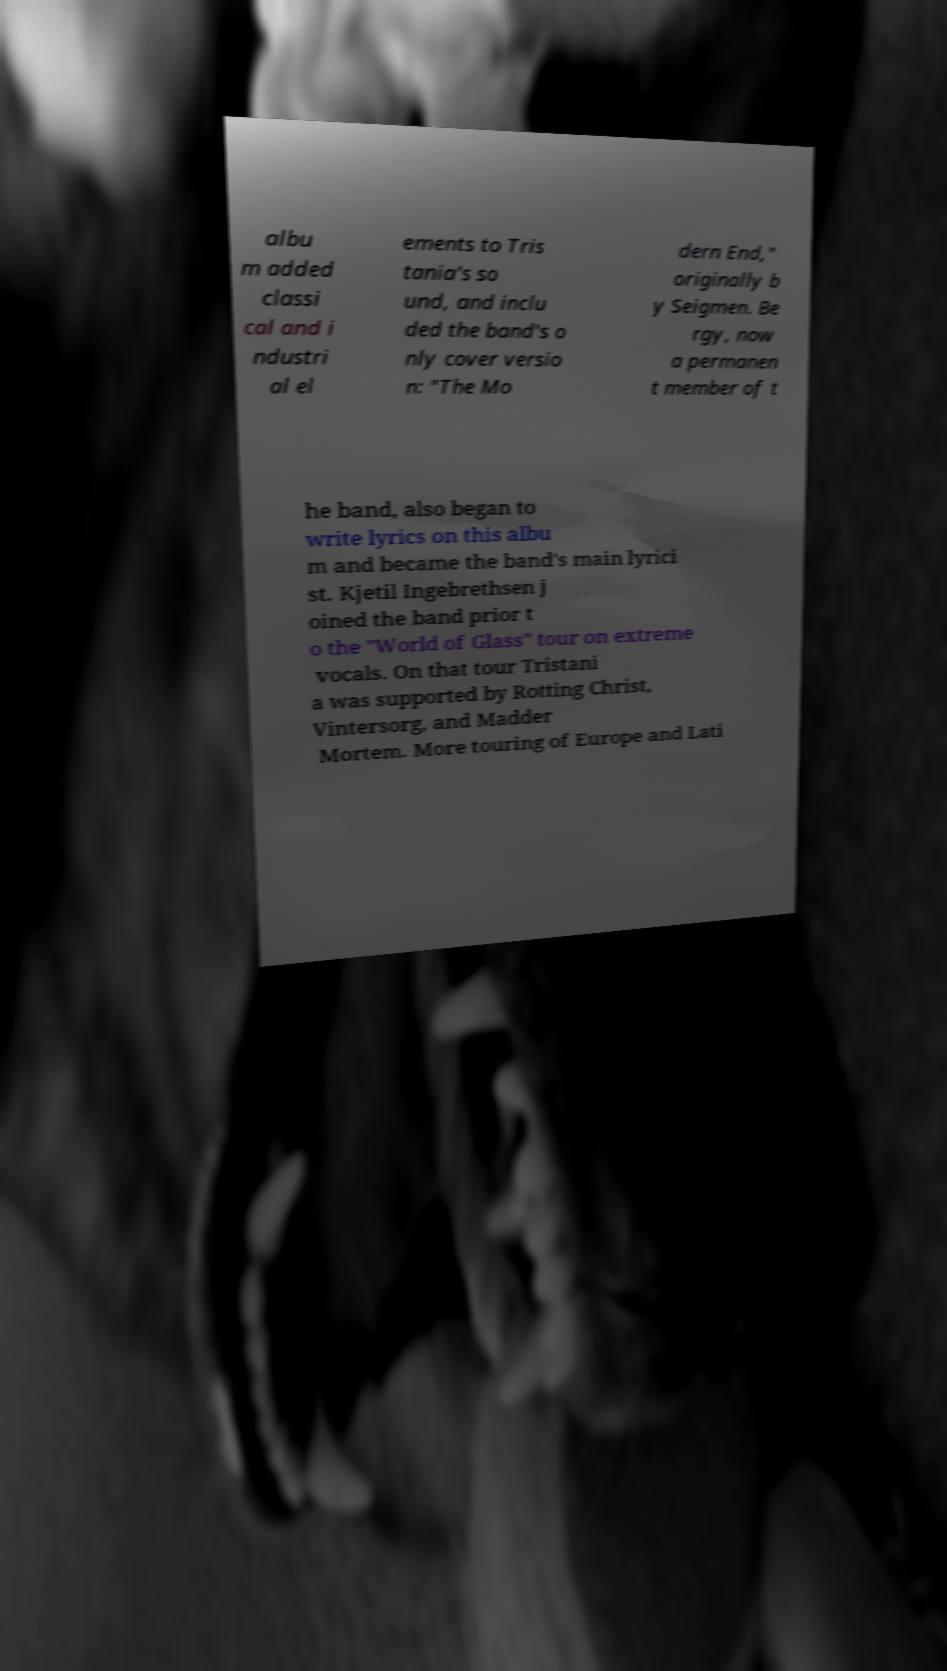There's text embedded in this image that I need extracted. Can you transcribe it verbatim? albu m added classi cal and i ndustri al el ements to Tris tania's so und, and inclu ded the band's o nly cover versio n: "The Mo dern End," originally b y Seigmen. Be rgy, now a permanen t member of t he band, also began to write lyrics on this albu m and became the band's main lyrici st. Kjetil Ingebrethsen j oined the band prior t o the "World of Glass" tour on extreme vocals. On that tour Tristani a was supported by Rotting Christ, Vintersorg, and Madder Mortem. More touring of Europe and Lati 